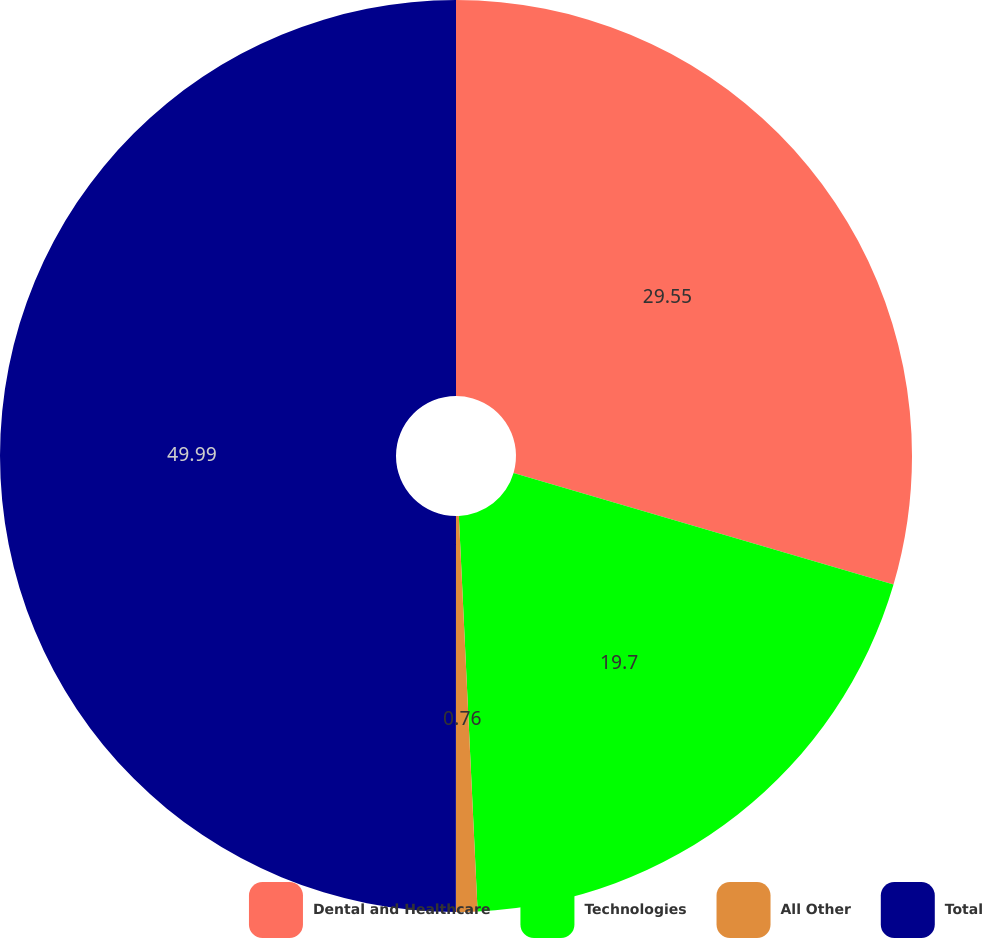<chart> <loc_0><loc_0><loc_500><loc_500><pie_chart><fcel>Dental and Healthcare<fcel>Technologies<fcel>All Other<fcel>Total<nl><fcel>29.55%<fcel>19.7%<fcel>0.76%<fcel>50.0%<nl></chart> 